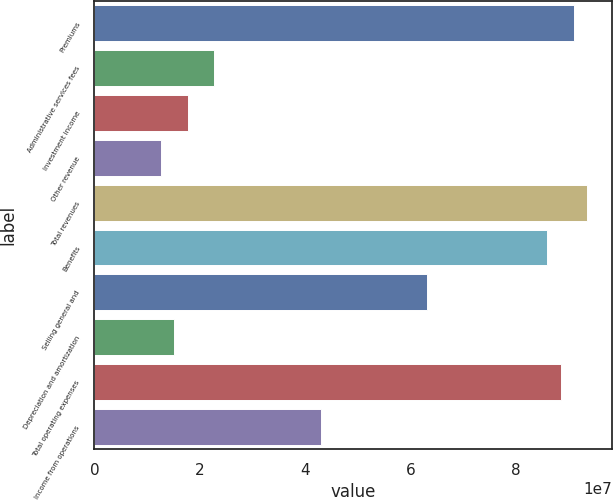Convert chart to OTSL. <chart><loc_0><loc_0><loc_500><loc_500><bar_chart><fcel>Premiums<fcel>Administrative services fees<fcel>Investment income<fcel>Other revenue<fcel>Total revenues<fcel>Benefits<fcel>Selling general and<fcel>Depreciation and amortization<fcel>Total operating expenses<fcel>Income from operations<nl><fcel>9.10439e+07<fcel>2.2761e+07<fcel>1.7703e+07<fcel>1.2645e+07<fcel>9.35729e+07<fcel>8.5986e+07<fcel>6.3225e+07<fcel>1.5174e+07<fcel>8.85149e+07<fcel>4.2993e+07<nl></chart> 